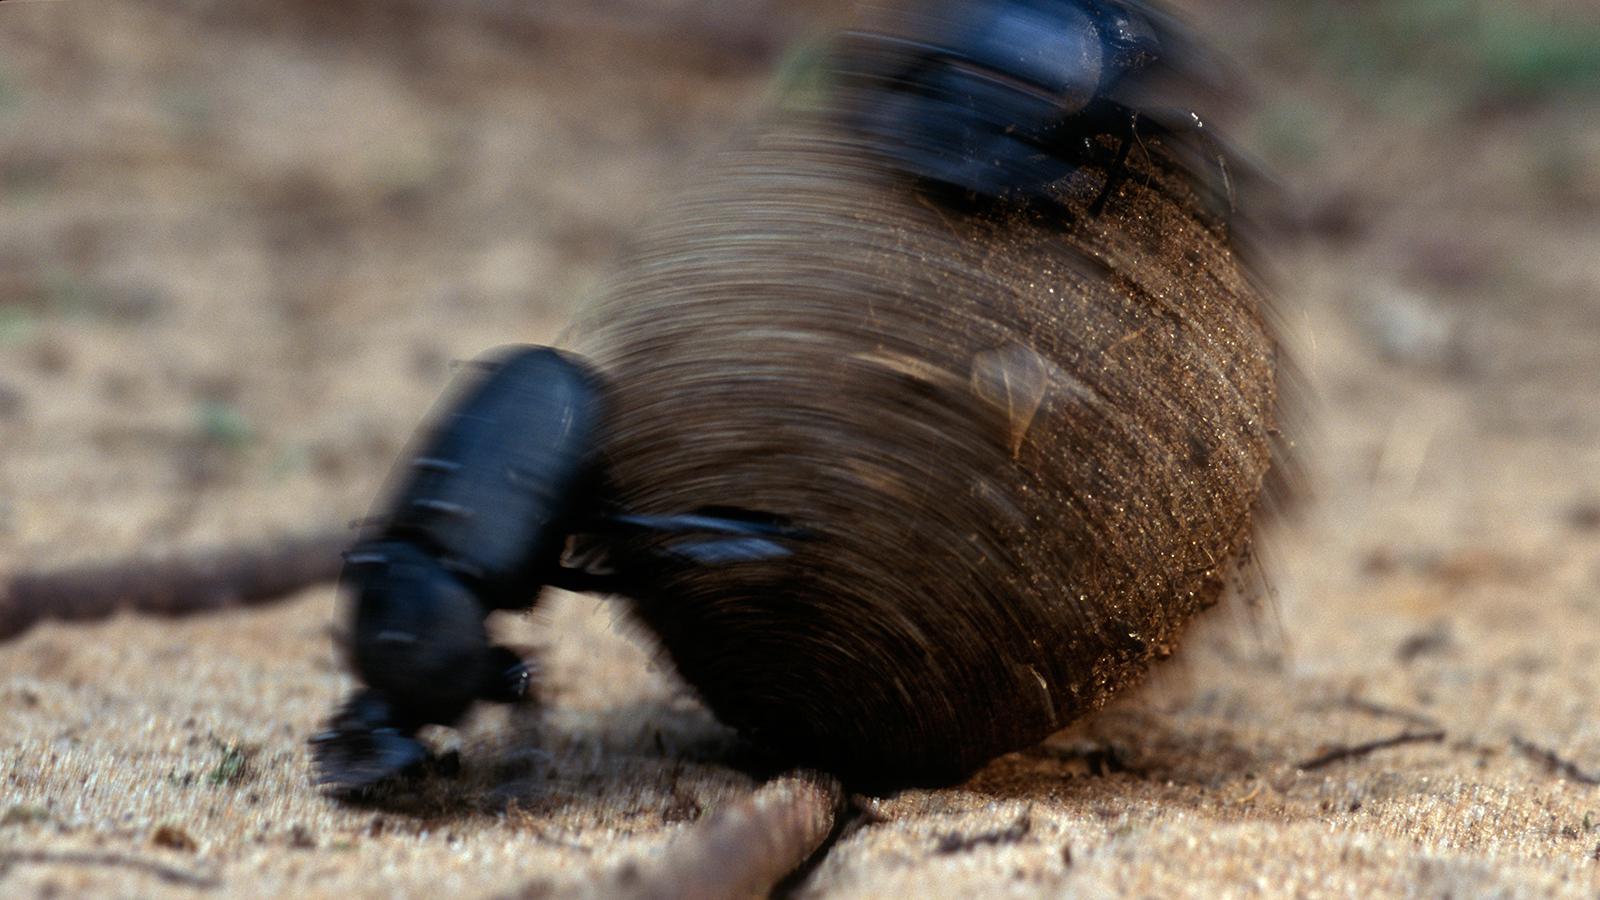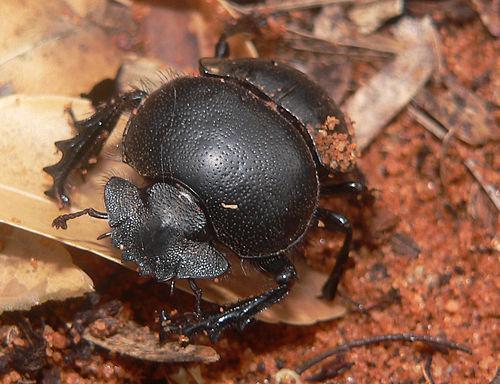The first image is the image on the left, the second image is the image on the right. For the images displayed, is the sentence "One of the beetles is not on a clod of dirt." factually correct? Answer yes or no. Yes. The first image is the image on the left, the second image is the image on the right. Analyze the images presented: Is the assertion "Each image shows just one beetle in contact with one round dung ball." valid? Answer yes or no. No. 